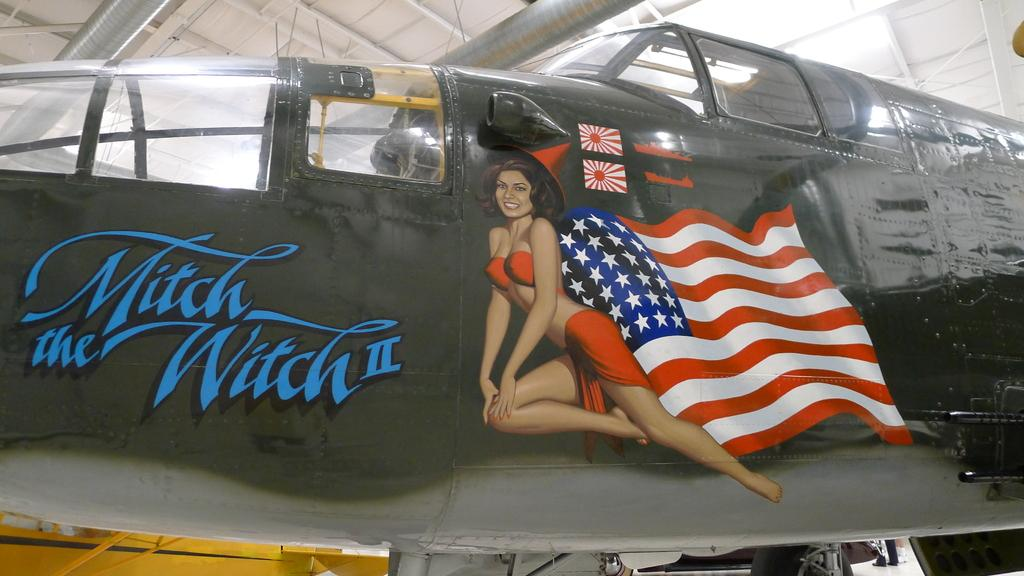Provide a one-sentence caption for the provided image. An American fighter plane that is called Mitch the Witch II. 